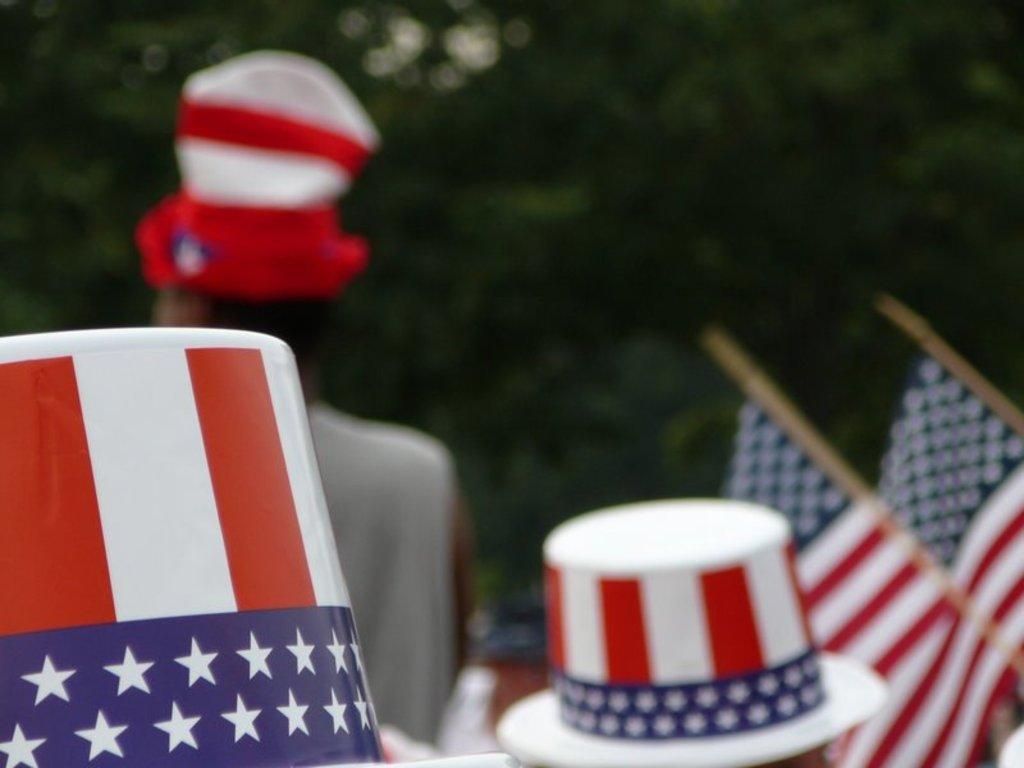How would you summarize this image in a sentence or two? In this picture we can see two caps here, on the right side there are two flags, we can see a person here, in the background there are trees. 